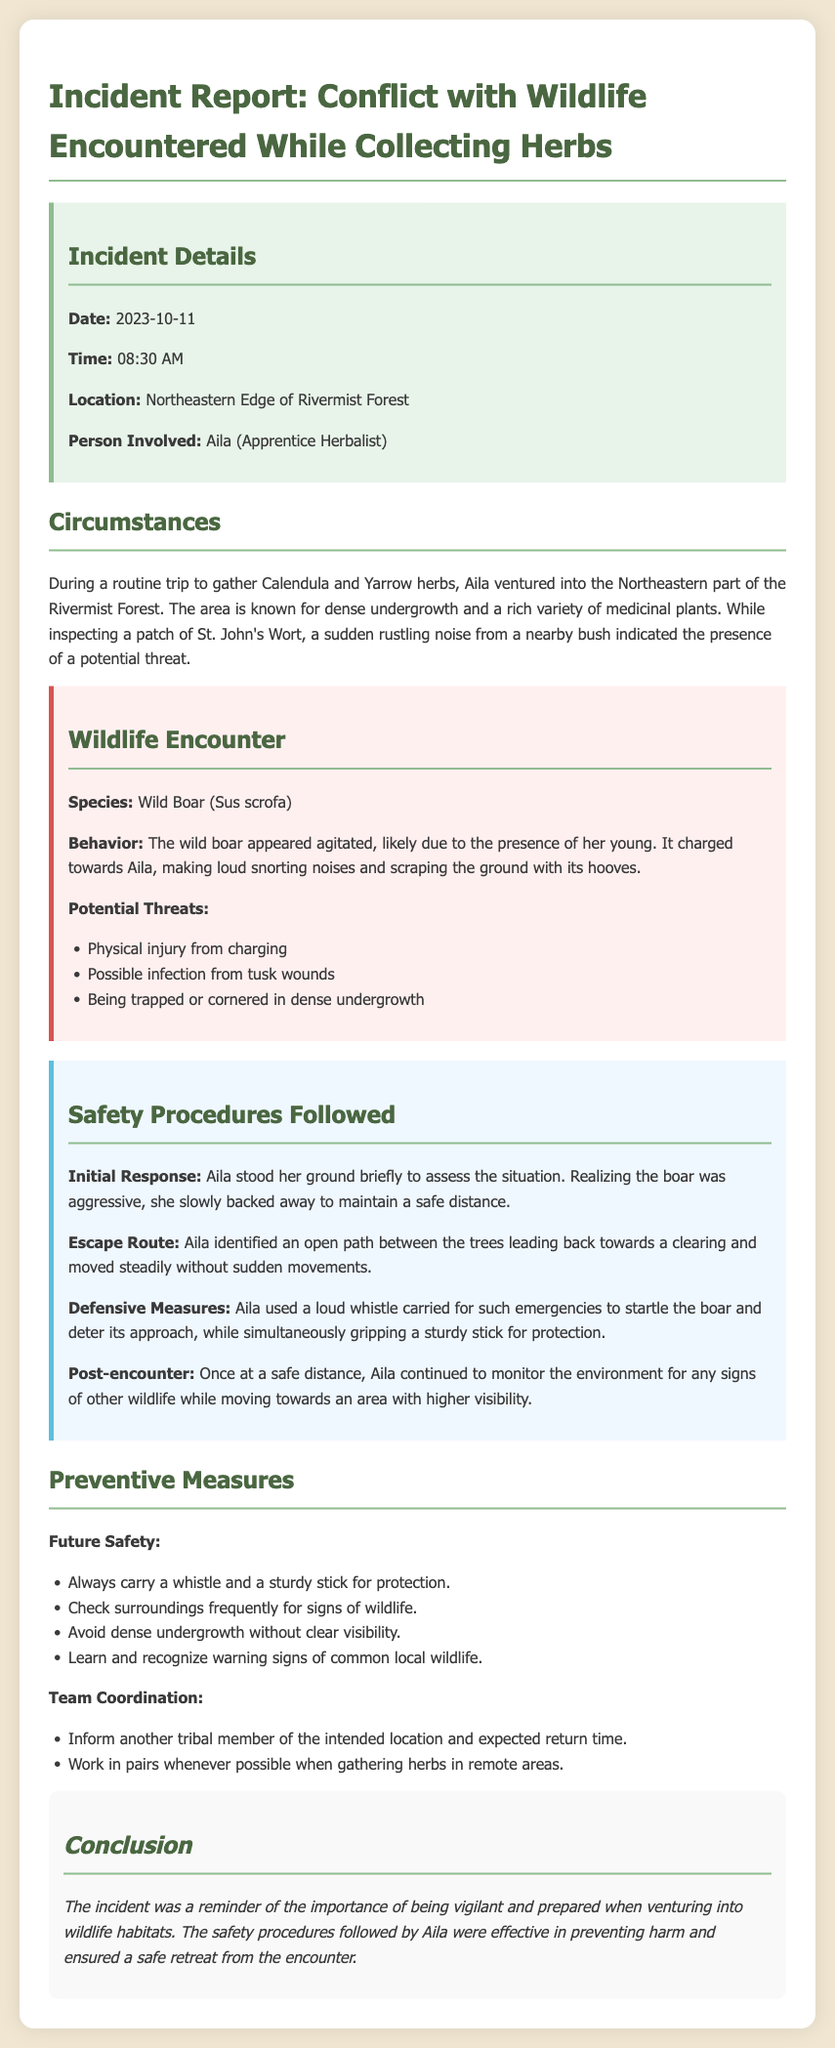what is the date of the incident? The date of the incident is stated in the document under incident details.
Answer: 2023-10-11 who is the person involved in the incident? The person involved is mentioned in the incident details section.
Answer: Aila what type of wildlife was encountered? The species involved in the encounter is listed under the wildlife encounter section.
Answer: Wild Boar what was Aila gathering when the incident occurred? The herbs Aila was collecting are specified in the circumstances section.
Answer: Calendula and Yarrow what aggressive behavior did the wild boar display? The behavior of the wild boar is described in the wildlife encounter section.
Answer: Charged towards Aila what initial response did Aila take during the encounter? The document outlines Aila's immediate actions in the safety procedures section.
Answer: Stood her ground what safety measure did Aila use to deter the boar? The defensive action taken by Aila is mentioned under safety procedures.
Answer: Loud whistle what is a preventive measure to avoid wildlife encounters in the future? Preventive measures are listed at the end of the document.
Answer: Carry a whistle and a sturdy stick how should tribal members coordinate when gathering herbs? Team coordination suggestions are provided in the preventive measures section.
Answer: Inform another tribal member 